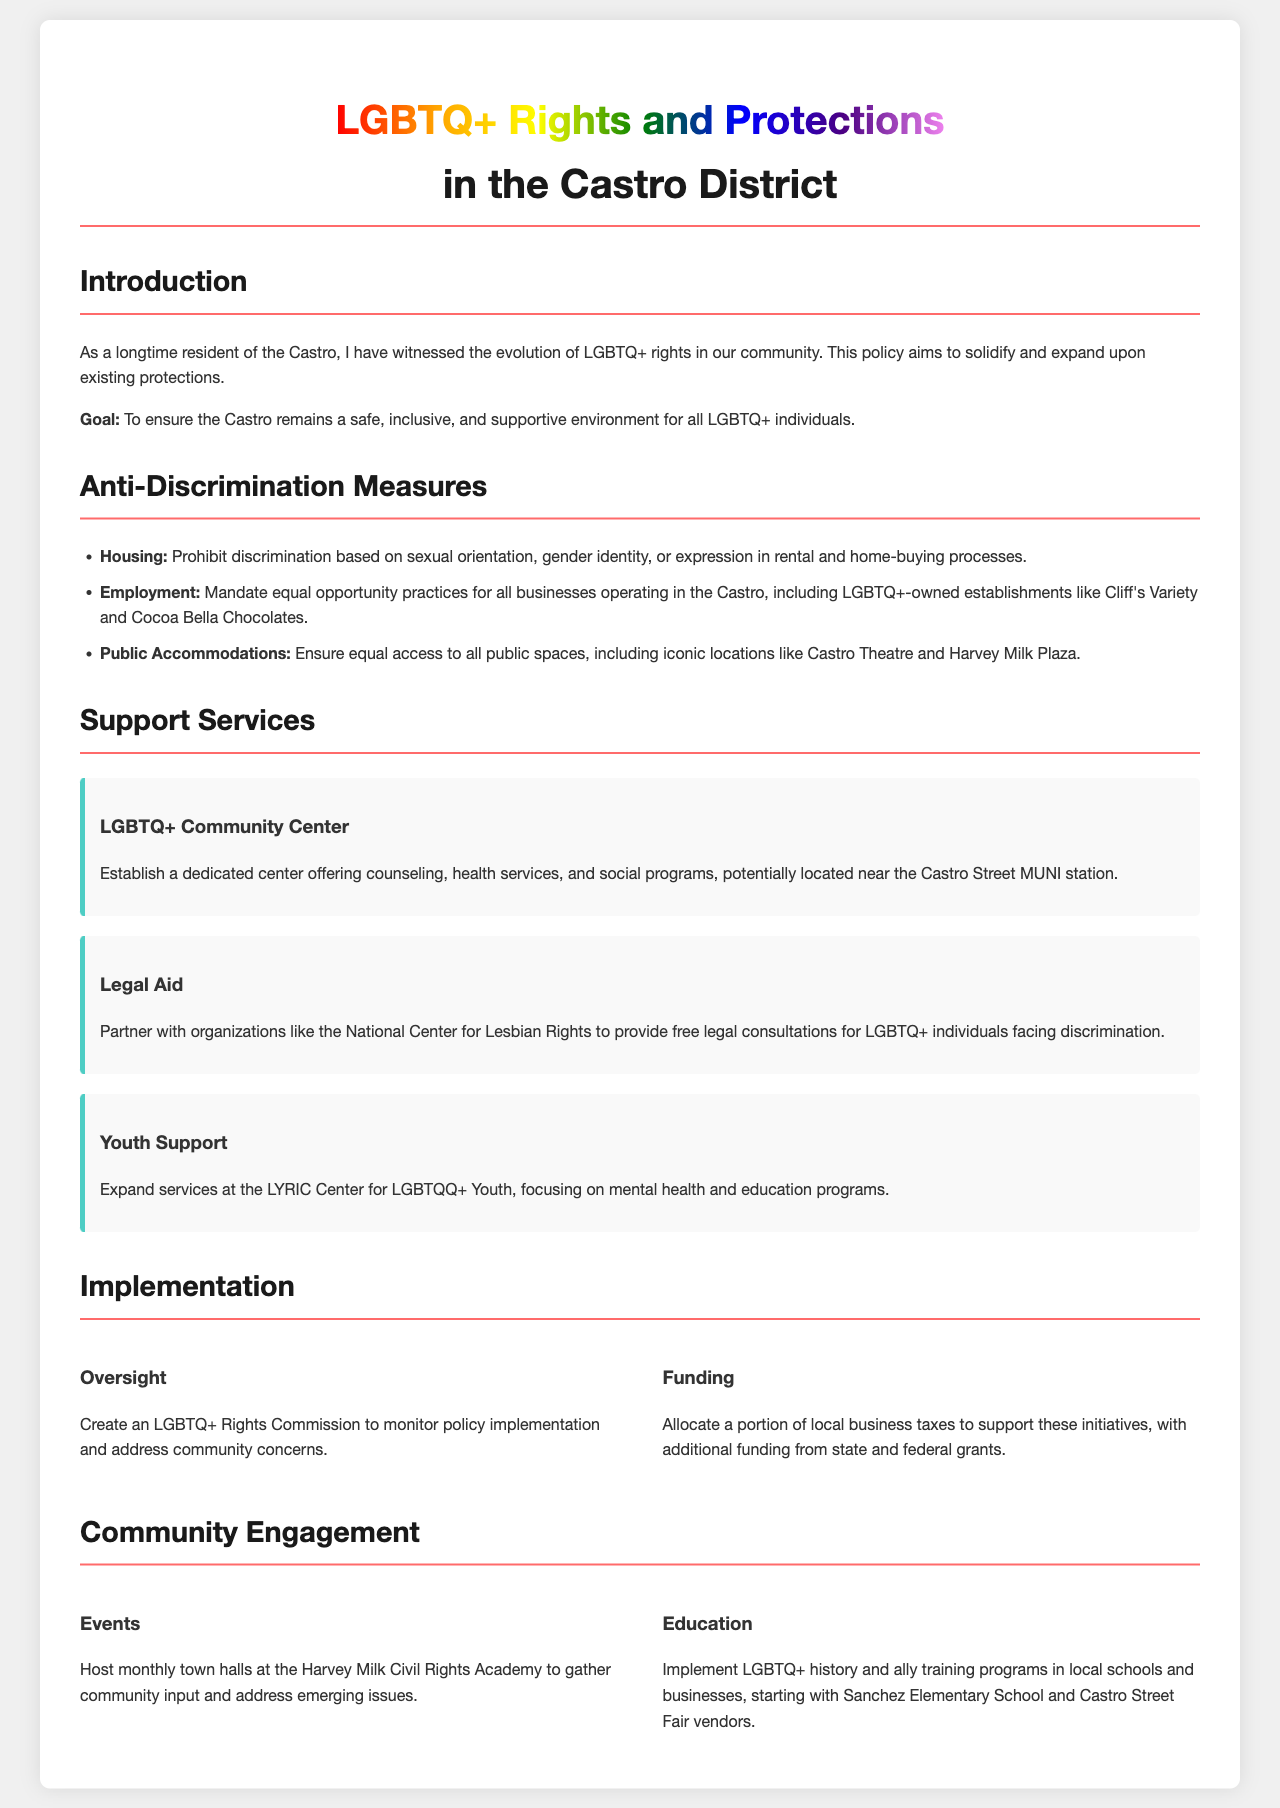What is the goal of the policy? The goal of the policy is stated explicitly in the introduction section of the document.
Answer: To ensure the Castro remains a safe, inclusive, and supportive environment for all LGBTQ+ individuals What organization is mentioned for legal aid? The document specifies an organization that will partner for legal aid in the support services section.
Answer: National Center for Lesbian Rights What is prohibited in housing? The anti-discrimination measures section outlines specific prohibitions regarding housing discrimination.
Answer: Discrimination based on sexual orientation, gender identity, or expression Where will the LGBTQ+ Community Center be potentially located? The support services section provides a possible location for the new LGBTQ+ Community Center.
Answer: Near the Castro Street MUNI station How often will town halls be hosted? The community engagement section provides the frequency of town hall events for gathering input.
Answer: Monthly What is created to monitor policy implementation? The implementation section specifies a body responsible for monitoring the policy.
Answer: LGBTQ+ Rights Commission Which local school will implement LGBTQ+ history programs? The education part of the community engagement section names a specific school for implementing these programs.
Answer: Sanchez Elementary School What is allocated to support the initiatives? The implementation section mentions what will be allocated for funding the initiatives provided by local sources.
Answer: A portion of local business taxes 